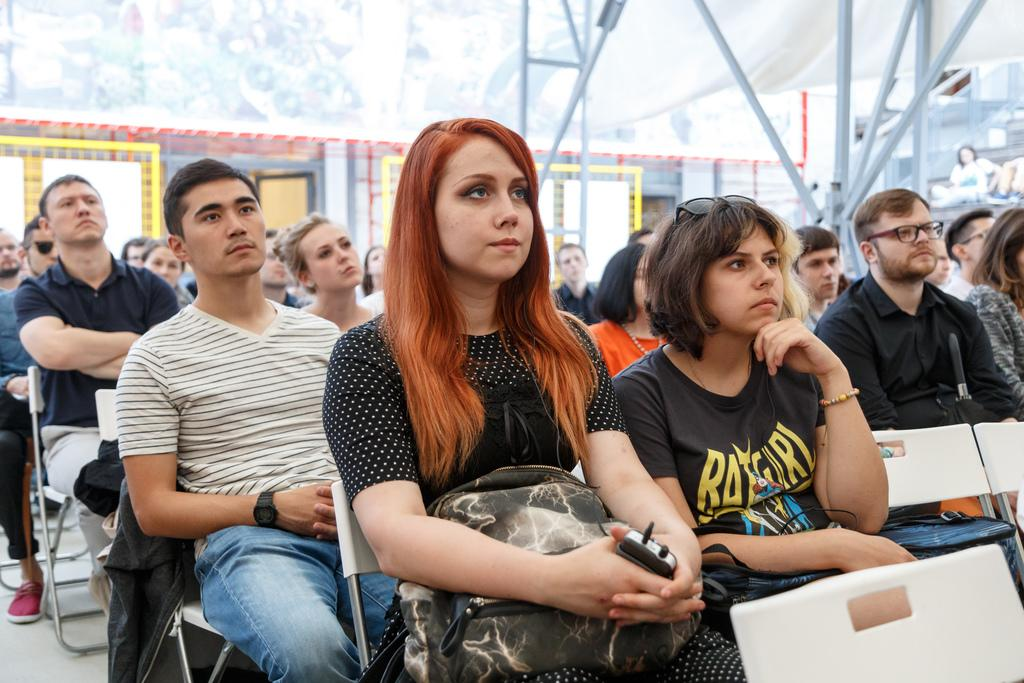What are the people in the image doing? The people in the image are sitting on chairs. What can be seen in the background of the image? There is a wall in the background of the image. Are there any openings or entrances visible in the image? Yes, there are doors in the image. What type of structural element can be seen in the image? There are rods in the image. What type of vase is being kicked by one of the people in the image? There is no vase present in the image, and no one is kicking anything. 